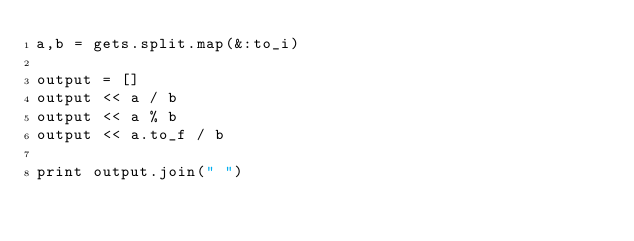<code> <loc_0><loc_0><loc_500><loc_500><_Ruby_>a,b = gets.split.map(&:to_i)

output = []
output << a / b
output << a % b
output << a.to_f / b

print output.join(" ")
</code> 